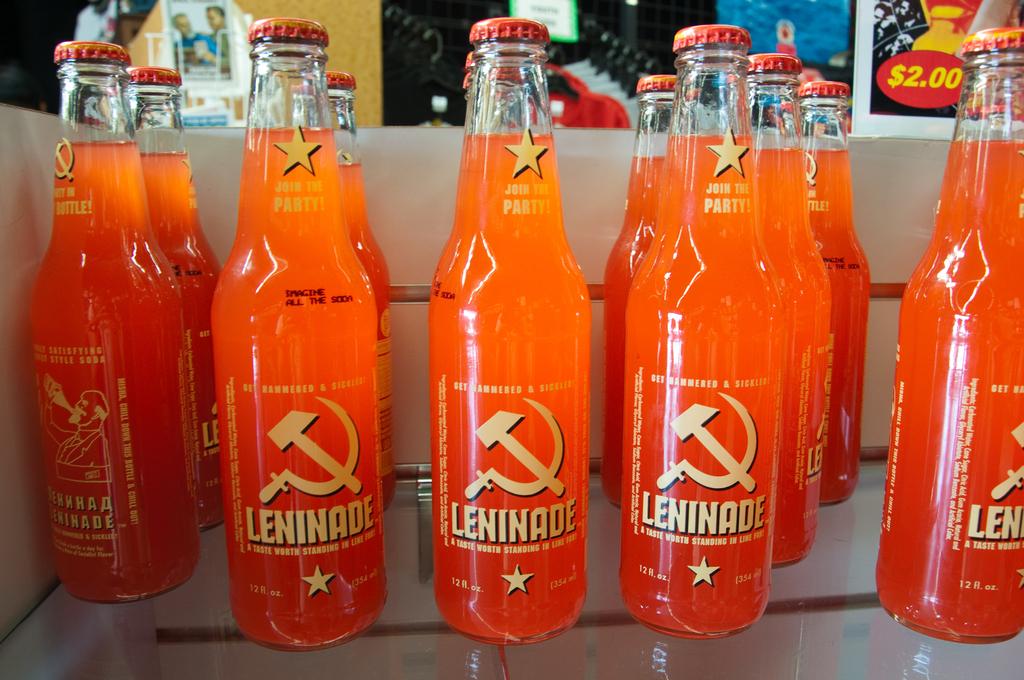What does it say under the stars?
Offer a terse response. Join the party. 